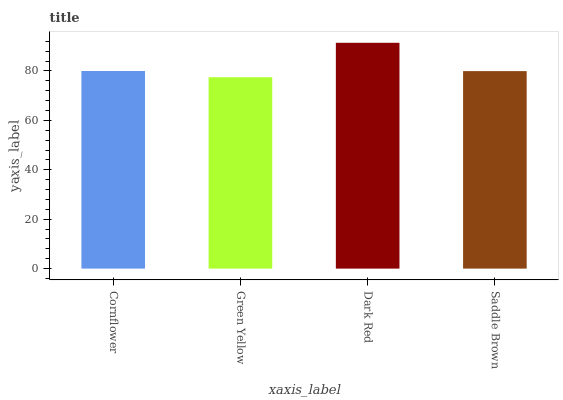Is Green Yellow the minimum?
Answer yes or no. Yes. Is Dark Red the maximum?
Answer yes or no. Yes. Is Dark Red the minimum?
Answer yes or no. No. Is Green Yellow the maximum?
Answer yes or no. No. Is Dark Red greater than Green Yellow?
Answer yes or no. Yes. Is Green Yellow less than Dark Red?
Answer yes or no. Yes. Is Green Yellow greater than Dark Red?
Answer yes or no. No. Is Dark Red less than Green Yellow?
Answer yes or no. No. Is Cornflower the high median?
Answer yes or no. Yes. Is Saddle Brown the low median?
Answer yes or no. Yes. Is Green Yellow the high median?
Answer yes or no. No. Is Dark Red the low median?
Answer yes or no. No. 